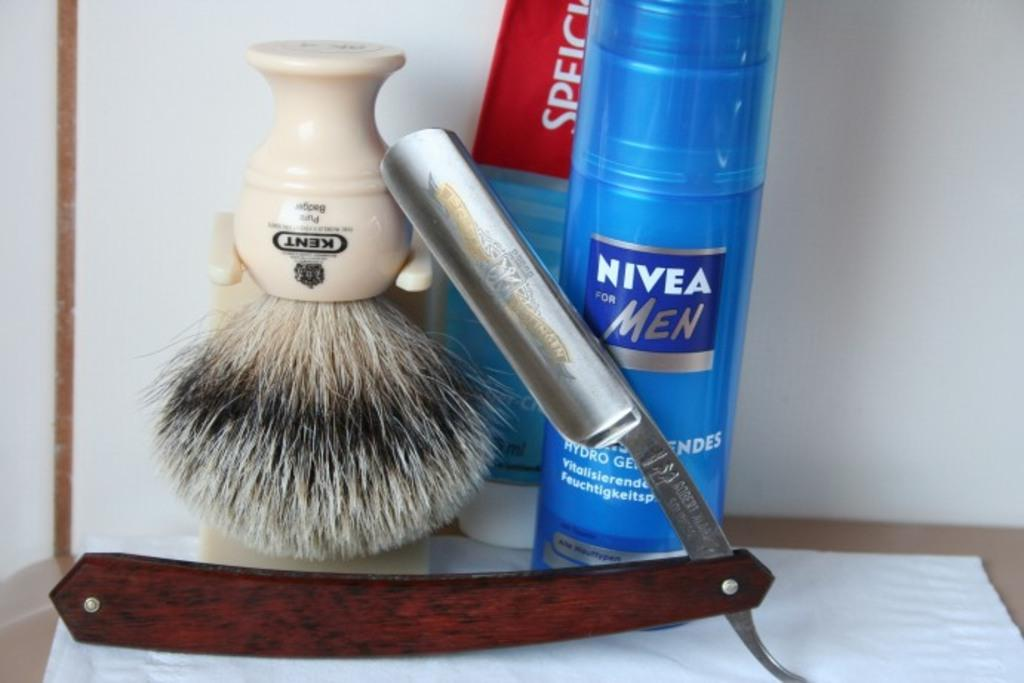<image>
Describe the image concisely. a blue bottle that has the word Nivea on it 